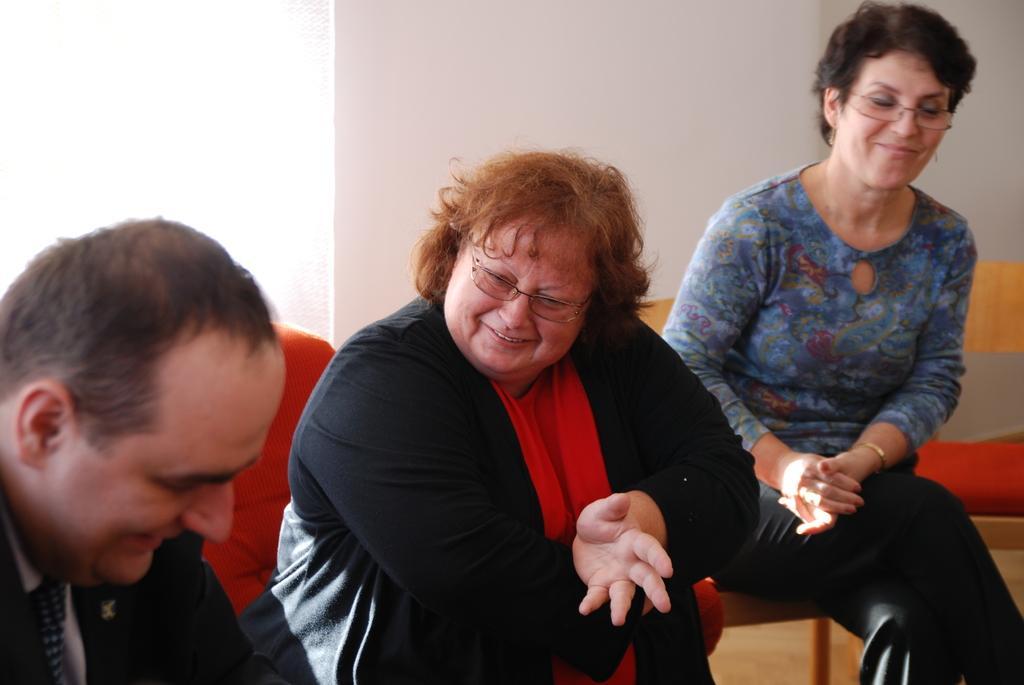Can you describe this image briefly? In this image there are three people in the middle. On the right side there is a woman who is sitting on the chair. In the background there is a wall. Behind them there is a chair. On the left side bottom there is a man. 